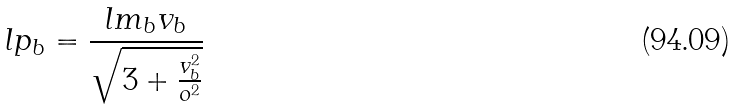Convert formula to latex. <formula><loc_0><loc_0><loc_500><loc_500>l p _ { b } = \frac { l m _ { b } v _ { b } } { \sqrt { 3 + \frac { v _ { b } ^ { 2 } } { o ^ { 2 } } } }</formula> 